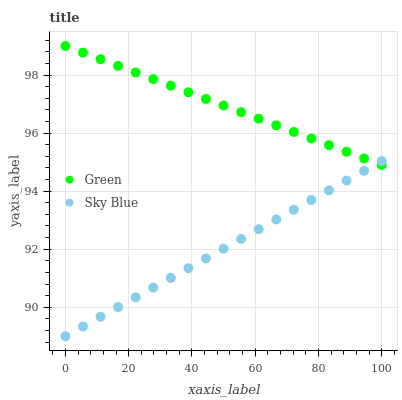Does Sky Blue have the minimum area under the curve?
Answer yes or no. Yes. Does Green have the maximum area under the curve?
Answer yes or no. Yes. Does Green have the minimum area under the curve?
Answer yes or no. No. Is Green the smoothest?
Answer yes or no. Yes. Is Sky Blue the roughest?
Answer yes or no. Yes. Is Green the roughest?
Answer yes or no. No. Does Sky Blue have the lowest value?
Answer yes or no. Yes. Does Green have the lowest value?
Answer yes or no. No. Does Green have the highest value?
Answer yes or no. Yes. Does Sky Blue intersect Green?
Answer yes or no. Yes. Is Sky Blue less than Green?
Answer yes or no. No. Is Sky Blue greater than Green?
Answer yes or no. No. 